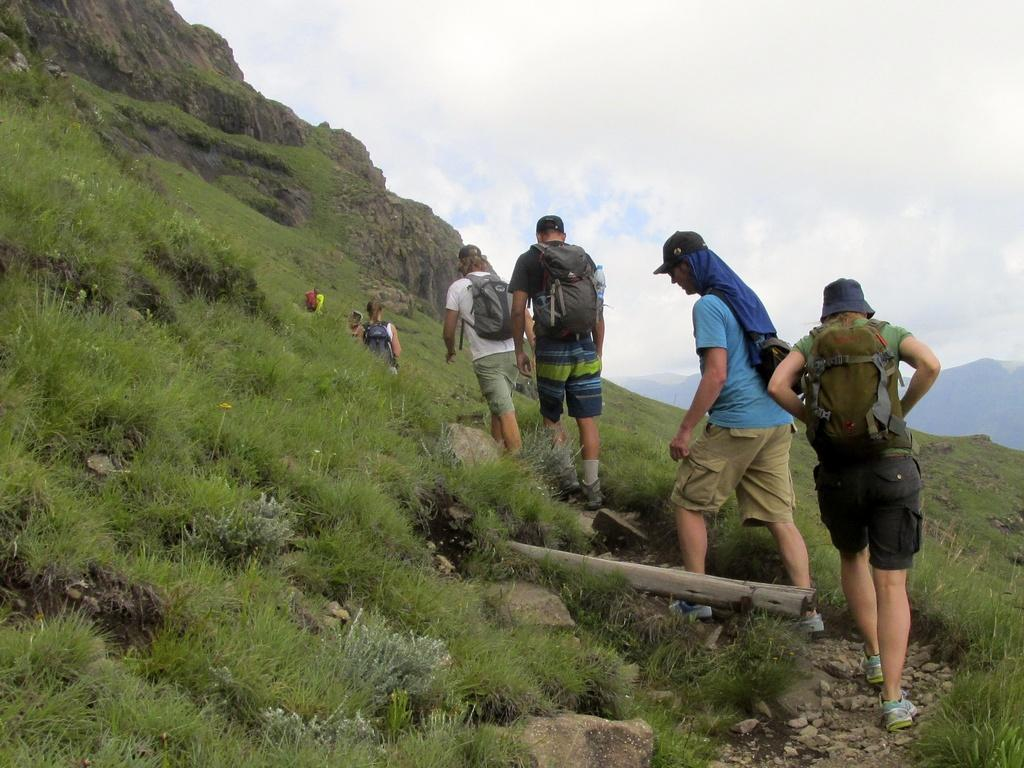What is the main subject in the center of the image? There are people in the center of the image. What type of surface is visible at the bottom of the image? There is grass on the surface at the bottom of the image. What other objects can be seen in the image? There are rocks in the image. What can be seen in the background of the image? There are mountains and the sky visible in the background of the image. What type of celery is being used as a suit in the image? There is no celery or suit present in the image. 